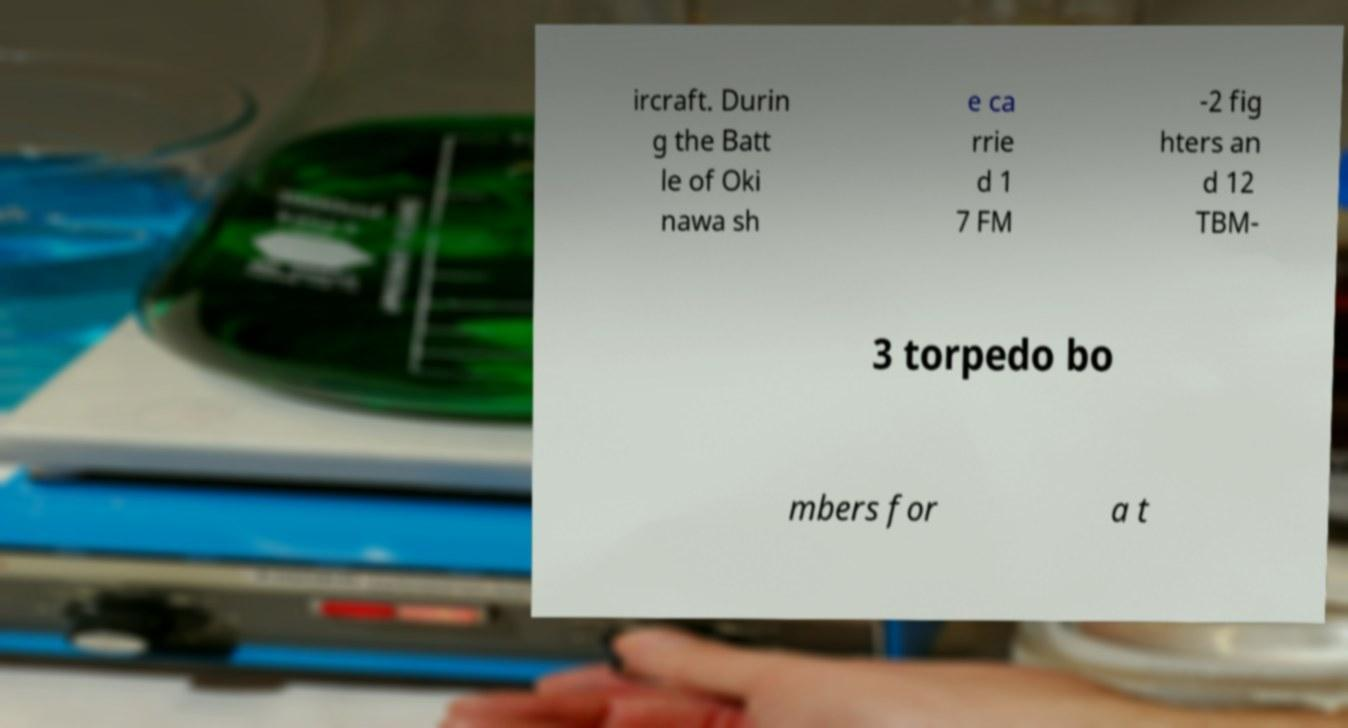For documentation purposes, I need the text within this image transcribed. Could you provide that? ircraft. Durin g the Batt le of Oki nawa sh e ca rrie d 1 7 FM -2 fig hters an d 12 TBM- 3 torpedo bo mbers for a t 